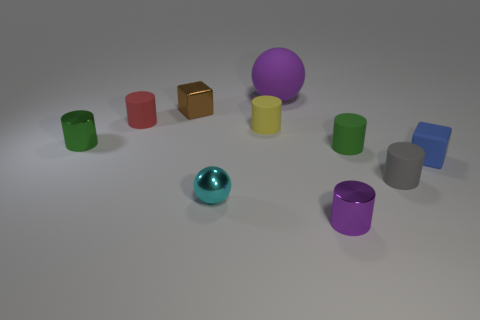Do the red object and the tiny blue thing have the same shape?
Your answer should be compact. No. The purple shiny cylinder has what size?
Keep it short and to the point. Small. What color is the small thing that is both in front of the gray object and to the right of the tiny cyan thing?
Give a very brief answer. Purple. Is the number of tiny blue blocks greater than the number of rubber cylinders?
Your answer should be very brief. No. What number of objects are red cubes or rubber objects that are to the left of the blue matte block?
Your answer should be compact. 5. Is the gray rubber object the same size as the green metallic object?
Offer a very short reply. Yes. Are there any things to the right of the brown metallic thing?
Offer a very short reply. Yes. What size is the metal object that is both in front of the small brown block and to the left of the tiny ball?
Your response must be concise. Small. How many objects are big purple balls or small gray cylinders?
Your response must be concise. 2. There is a red object; does it have the same size as the green cylinder that is right of the cyan ball?
Provide a succinct answer. Yes. 